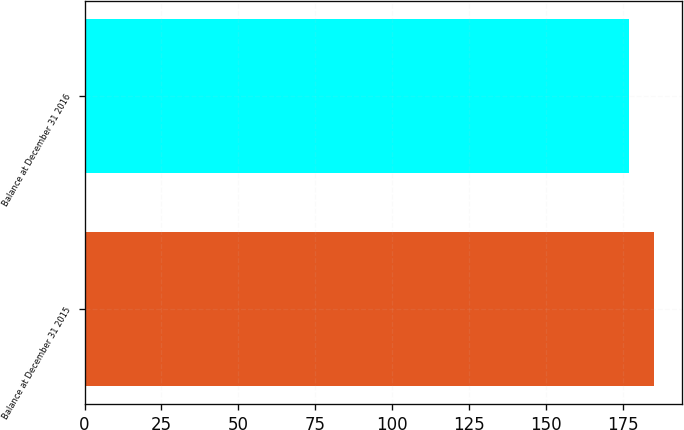Convert chart. <chart><loc_0><loc_0><loc_500><loc_500><bar_chart><fcel>Balance at December 31 2015<fcel>Balance at December 31 2016<nl><fcel>185<fcel>177<nl></chart> 